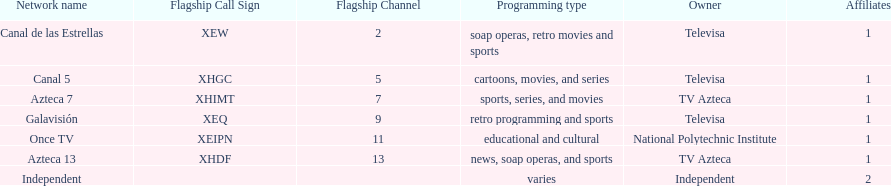Azteca 7 and azteca 13 are both owned by whom? TV Azteca. Give me the full table as a dictionary. {'header': ['Network name', 'Flagship Call Sign', 'Flagship Channel', 'Programming type', 'Owner', 'Affiliates'], 'rows': [['Canal de las Estrellas', 'XEW', '2', 'soap operas, retro movies and sports', 'Televisa', '1'], ['Canal 5', 'XHGC', '5', 'cartoons, movies, and series', 'Televisa', '1'], ['Azteca 7', 'XHIMT', '7', 'sports, series, and movies', 'TV Azteca', '1'], ['Galavisión', 'XEQ', '9', 'retro programming and sports', 'Televisa', '1'], ['Once TV', 'XEIPN', '11', 'educational and cultural', 'National Polytechnic Institute', '1'], ['Azteca 13', 'XHDF', '13', 'news, soap operas, and sports', 'TV Azteca', '1'], ['Independent', '', '', 'varies', 'Independent', '2']]} 